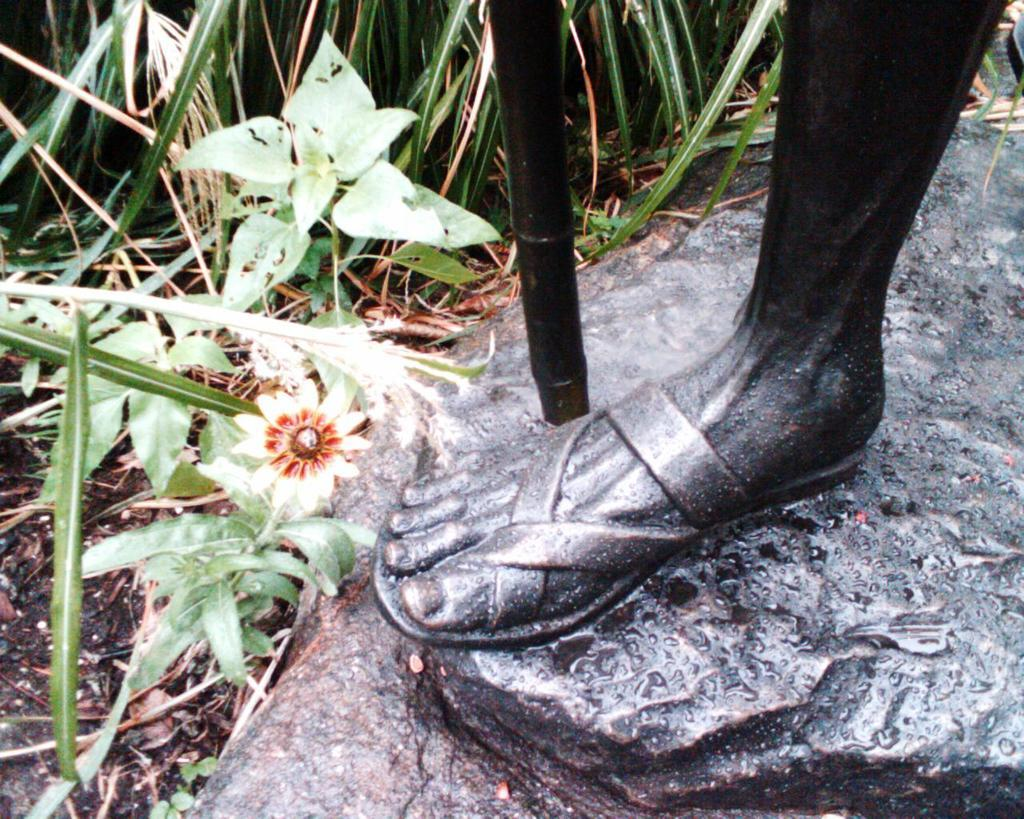What can be found on the right side of the image? There is a statue on the right side of the image. What is located at the top side of the image? There are plants at the top side of the image. What type of bead is hanging from the statue in the image? There is no bead present in the image; it only features a statue and plants. How does the watch move in the image? There is no watch present in the image, so it cannot be determined how it would move. 